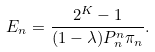Convert formula to latex. <formula><loc_0><loc_0><loc_500><loc_500>E _ { n } = \frac { 2 ^ { K } - 1 } { ( 1 - \lambda ) P ^ { n } _ { n } \pi _ { n } } .</formula> 